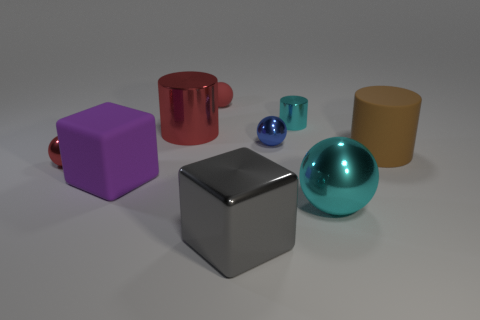Is the blue metallic object the same shape as the small red matte object?
Provide a short and direct response. Yes. There is a large brown thing that is the same shape as the tiny cyan thing; what is its material?
Keep it short and to the point. Rubber. There is a big rubber thing that is right of the blue metallic object; does it have the same shape as the gray thing?
Your response must be concise. No. How many big objects are either red cylinders or green rubber spheres?
Ensure brevity in your answer.  1. Are there an equal number of cyan spheres behind the purple thing and tiny objects on the left side of the rubber cylinder?
Your answer should be very brief. No. How many other objects are there of the same color as the tiny matte ball?
Ensure brevity in your answer.  2. There is a big shiny sphere; does it have the same color as the small shiny sphere behind the brown thing?
Keep it short and to the point. No. How many cyan things are either big rubber objects or cubes?
Provide a succinct answer. 0. Are there the same number of large brown things that are to the left of the big gray object and brown rubber objects?
Keep it short and to the point. No. Is there any other thing that is the same size as the red shiny sphere?
Give a very brief answer. Yes. 